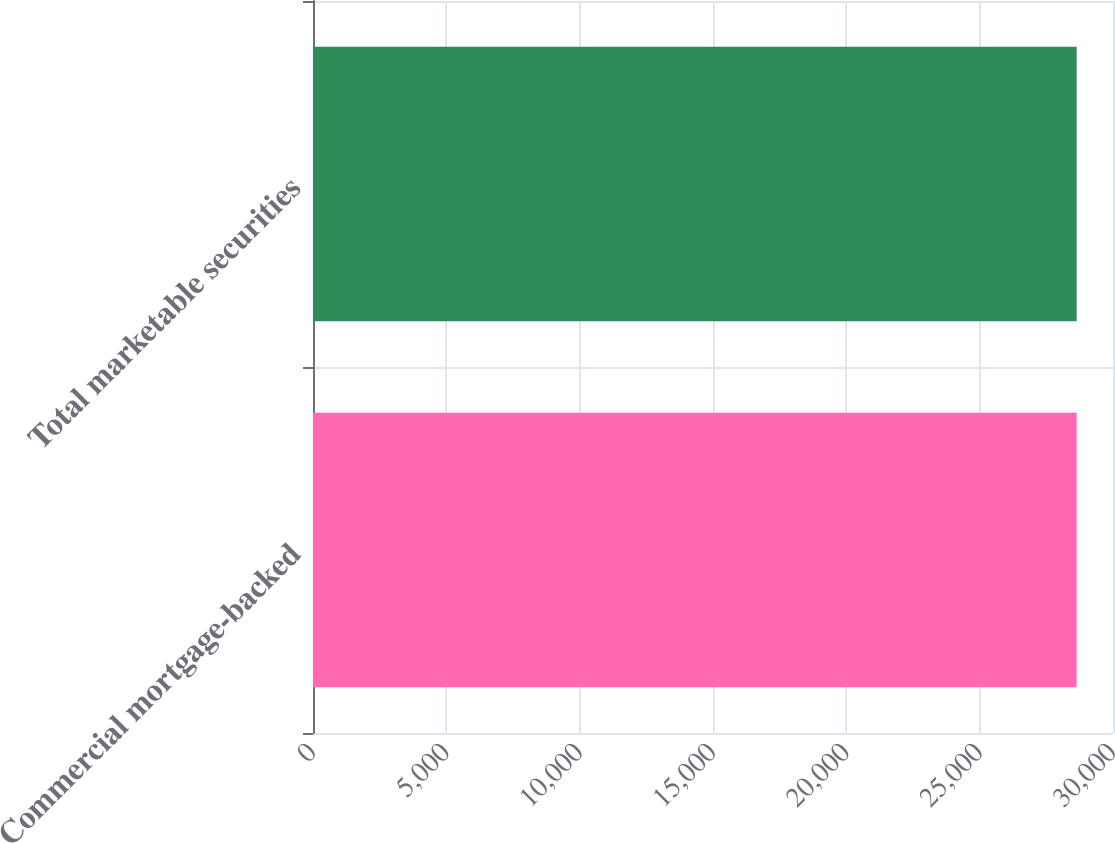Convert chart. <chart><loc_0><loc_0><loc_500><loc_500><bar_chart><fcel>Commercial mortgage-backed<fcel>Total marketable securities<nl><fcel>28638<fcel>28638.1<nl></chart> 